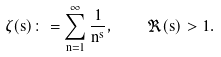<formula> <loc_0><loc_0><loc_500><loc_500>\zeta ( s ) \colon = \sum _ { n = 1 } ^ { \infty } \frac { 1 } { n ^ { s } } , \quad \Re ( s ) > 1 .</formula> 